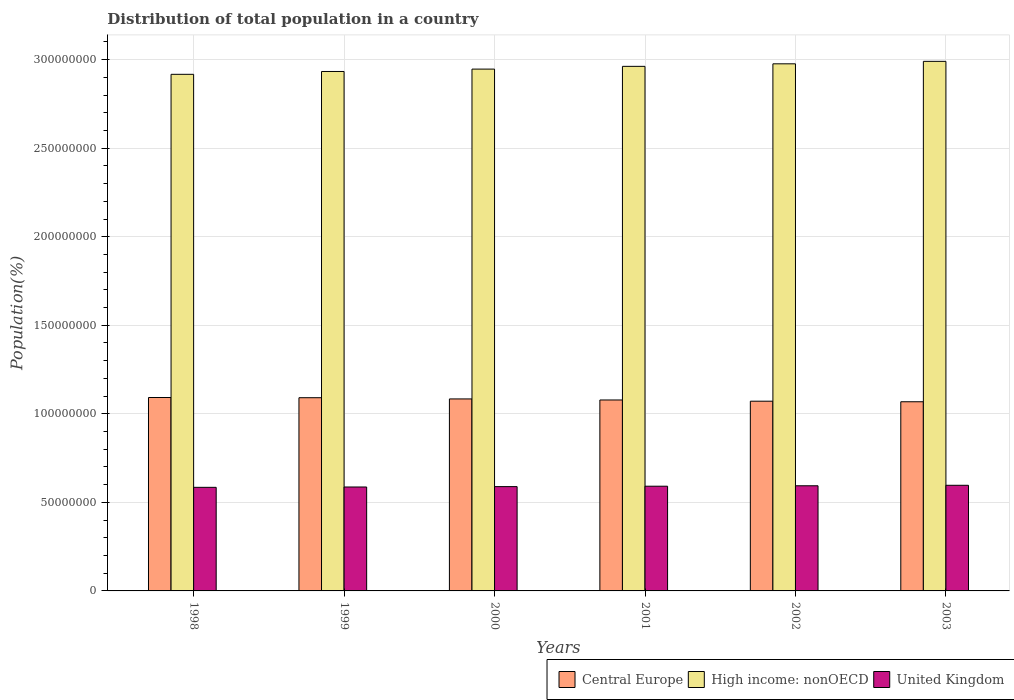How many different coloured bars are there?
Your response must be concise. 3. Are the number of bars on each tick of the X-axis equal?
Your answer should be very brief. Yes. How many bars are there on the 6th tick from the left?
Give a very brief answer. 3. How many bars are there on the 1st tick from the right?
Make the answer very short. 3. In how many cases, is the number of bars for a given year not equal to the number of legend labels?
Your answer should be compact. 0. What is the population of in United Kingdom in 2001?
Give a very brief answer. 5.91e+07. Across all years, what is the maximum population of in High income: nonOECD?
Give a very brief answer. 2.99e+08. Across all years, what is the minimum population of in United Kingdom?
Provide a succinct answer. 5.85e+07. What is the total population of in High income: nonOECD in the graph?
Offer a terse response. 1.77e+09. What is the difference between the population of in Central Europe in 2000 and that in 2001?
Keep it short and to the point. 5.94e+05. What is the difference between the population of in United Kingdom in 2000 and the population of in Central Europe in 1998?
Make the answer very short. -5.03e+07. What is the average population of in United Kingdom per year?
Offer a terse response. 5.90e+07. In the year 2001, what is the difference between the population of in Central Europe and population of in High income: nonOECD?
Your response must be concise. -1.88e+08. What is the ratio of the population of in Central Europe in 1998 to that in 2003?
Provide a short and direct response. 1.02. Is the population of in High income: nonOECD in 1998 less than that in 2000?
Your answer should be very brief. Yes. Is the difference between the population of in Central Europe in 2000 and 2002 greater than the difference between the population of in High income: nonOECD in 2000 and 2002?
Give a very brief answer. Yes. What is the difference between the highest and the second highest population of in Central Europe?
Your response must be concise. 1.14e+05. What is the difference between the highest and the lowest population of in United Kingdom?
Ensure brevity in your answer.  1.16e+06. In how many years, is the population of in Central Europe greater than the average population of in Central Europe taken over all years?
Offer a terse response. 3. Is the sum of the population of in United Kingdom in 1998 and 2002 greater than the maximum population of in High income: nonOECD across all years?
Provide a short and direct response. No. What does the 2nd bar from the left in 1998 represents?
Ensure brevity in your answer.  High income: nonOECD. What does the 2nd bar from the right in 2003 represents?
Keep it short and to the point. High income: nonOECD. How many bars are there?
Make the answer very short. 18. Are all the bars in the graph horizontal?
Your answer should be compact. No. How many years are there in the graph?
Make the answer very short. 6. What is the difference between two consecutive major ticks on the Y-axis?
Your response must be concise. 5.00e+07. Are the values on the major ticks of Y-axis written in scientific E-notation?
Offer a terse response. No. Does the graph contain any zero values?
Your response must be concise. No. Does the graph contain grids?
Keep it short and to the point. Yes. How many legend labels are there?
Give a very brief answer. 3. How are the legend labels stacked?
Your response must be concise. Horizontal. What is the title of the graph?
Your answer should be compact. Distribution of total population in a country. What is the label or title of the X-axis?
Provide a short and direct response. Years. What is the label or title of the Y-axis?
Offer a terse response. Population(%). What is the Population(%) of Central Europe in 1998?
Offer a very short reply. 1.09e+08. What is the Population(%) in High income: nonOECD in 1998?
Make the answer very short. 2.92e+08. What is the Population(%) of United Kingdom in 1998?
Provide a succinct answer. 5.85e+07. What is the Population(%) of Central Europe in 1999?
Offer a terse response. 1.09e+08. What is the Population(%) of High income: nonOECD in 1999?
Your answer should be very brief. 2.93e+08. What is the Population(%) of United Kingdom in 1999?
Offer a very short reply. 5.87e+07. What is the Population(%) of Central Europe in 2000?
Make the answer very short. 1.08e+08. What is the Population(%) in High income: nonOECD in 2000?
Your answer should be very brief. 2.95e+08. What is the Population(%) of United Kingdom in 2000?
Provide a succinct answer. 5.89e+07. What is the Population(%) in Central Europe in 2001?
Offer a very short reply. 1.08e+08. What is the Population(%) in High income: nonOECD in 2001?
Provide a short and direct response. 2.96e+08. What is the Population(%) in United Kingdom in 2001?
Provide a succinct answer. 5.91e+07. What is the Population(%) in Central Europe in 2002?
Ensure brevity in your answer.  1.07e+08. What is the Population(%) of High income: nonOECD in 2002?
Ensure brevity in your answer.  2.98e+08. What is the Population(%) of United Kingdom in 2002?
Offer a very short reply. 5.94e+07. What is the Population(%) in Central Europe in 2003?
Your response must be concise. 1.07e+08. What is the Population(%) in High income: nonOECD in 2003?
Give a very brief answer. 2.99e+08. What is the Population(%) in United Kingdom in 2003?
Provide a succinct answer. 5.96e+07. Across all years, what is the maximum Population(%) in Central Europe?
Give a very brief answer. 1.09e+08. Across all years, what is the maximum Population(%) of High income: nonOECD?
Keep it short and to the point. 2.99e+08. Across all years, what is the maximum Population(%) of United Kingdom?
Provide a succinct answer. 5.96e+07. Across all years, what is the minimum Population(%) of Central Europe?
Make the answer very short. 1.07e+08. Across all years, what is the minimum Population(%) of High income: nonOECD?
Your answer should be compact. 2.92e+08. Across all years, what is the minimum Population(%) of United Kingdom?
Keep it short and to the point. 5.85e+07. What is the total Population(%) of Central Europe in the graph?
Your answer should be very brief. 6.48e+08. What is the total Population(%) in High income: nonOECD in the graph?
Offer a terse response. 1.77e+09. What is the total Population(%) of United Kingdom in the graph?
Offer a terse response. 3.54e+08. What is the difference between the Population(%) of Central Europe in 1998 and that in 1999?
Your answer should be very brief. 1.14e+05. What is the difference between the Population(%) in High income: nonOECD in 1998 and that in 1999?
Your answer should be compact. -1.60e+06. What is the difference between the Population(%) of United Kingdom in 1998 and that in 1999?
Your answer should be very brief. -1.95e+05. What is the difference between the Population(%) of Central Europe in 1998 and that in 2000?
Provide a short and direct response. 8.02e+05. What is the difference between the Population(%) in High income: nonOECD in 1998 and that in 2000?
Provide a short and direct response. -2.95e+06. What is the difference between the Population(%) in United Kingdom in 1998 and that in 2000?
Provide a short and direct response. -4.05e+05. What is the difference between the Population(%) of Central Europe in 1998 and that in 2001?
Offer a terse response. 1.40e+06. What is the difference between the Population(%) in High income: nonOECD in 1998 and that in 2001?
Make the answer very short. -4.50e+06. What is the difference between the Population(%) in United Kingdom in 1998 and that in 2001?
Keep it short and to the point. -6.33e+05. What is the difference between the Population(%) in Central Europe in 1998 and that in 2002?
Provide a succinct answer. 2.08e+06. What is the difference between the Population(%) of High income: nonOECD in 1998 and that in 2002?
Offer a very short reply. -5.93e+06. What is the difference between the Population(%) of United Kingdom in 1998 and that in 2002?
Provide a short and direct response. -8.83e+05. What is the difference between the Population(%) of Central Europe in 1998 and that in 2003?
Give a very brief answer. 2.40e+06. What is the difference between the Population(%) of High income: nonOECD in 1998 and that in 2003?
Provide a succinct answer. -7.32e+06. What is the difference between the Population(%) of United Kingdom in 1998 and that in 2003?
Your answer should be very brief. -1.16e+06. What is the difference between the Population(%) in Central Europe in 1999 and that in 2000?
Give a very brief answer. 6.87e+05. What is the difference between the Population(%) of High income: nonOECD in 1999 and that in 2000?
Offer a very short reply. -1.35e+06. What is the difference between the Population(%) in United Kingdom in 1999 and that in 2000?
Your answer should be very brief. -2.10e+05. What is the difference between the Population(%) of Central Europe in 1999 and that in 2001?
Make the answer very short. 1.28e+06. What is the difference between the Population(%) of High income: nonOECD in 1999 and that in 2001?
Your answer should be very brief. -2.90e+06. What is the difference between the Population(%) in United Kingdom in 1999 and that in 2001?
Your response must be concise. -4.37e+05. What is the difference between the Population(%) of Central Europe in 1999 and that in 2002?
Offer a very short reply. 1.96e+06. What is the difference between the Population(%) in High income: nonOECD in 1999 and that in 2002?
Ensure brevity in your answer.  -4.33e+06. What is the difference between the Population(%) in United Kingdom in 1999 and that in 2002?
Provide a succinct answer. -6.88e+05. What is the difference between the Population(%) in Central Europe in 1999 and that in 2003?
Your answer should be compact. 2.28e+06. What is the difference between the Population(%) of High income: nonOECD in 1999 and that in 2003?
Offer a terse response. -5.72e+06. What is the difference between the Population(%) in United Kingdom in 1999 and that in 2003?
Offer a terse response. -9.65e+05. What is the difference between the Population(%) in Central Europe in 2000 and that in 2001?
Ensure brevity in your answer.  5.94e+05. What is the difference between the Population(%) of High income: nonOECD in 2000 and that in 2001?
Offer a very short reply. -1.55e+06. What is the difference between the Population(%) in United Kingdom in 2000 and that in 2001?
Keep it short and to the point. -2.27e+05. What is the difference between the Population(%) of Central Europe in 2000 and that in 2002?
Provide a succinct answer. 1.28e+06. What is the difference between the Population(%) in High income: nonOECD in 2000 and that in 2002?
Give a very brief answer. -2.98e+06. What is the difference between the Population(%) of United Kingdom in 2000 and that in 2002?
Provide a succinct answer. -4.78e+05. What is the difference between the Population(%) of Central Europe in 2000 and that in 2003?
Your answer should be very brief. 1.60e+06. What is the difference between the Population(%) in High income: nonOECD in 2000 and that in 2003?
Offer a very short reply. -4.37e+06. What is the difference between the Population(%) of United Kingdom in 2000 and that in 2003?
Offer a terse response. -7.55e+05. What is the difference between the Population(%) in Central Europe in 2001 and that in 2002?
Keep it short and to the point. 6.83e+05. What is the difference between the Population(%) of High income: nonOECD in 2001 and that in 2002?
Make the answer very short. -1.43e+06. What is the difference between the Population(%) in United Kingdom in 2001 and that in 2002?
Provide a succinct answer. -2.51e+05. What is the difference between the Population(%) in Central Europe in 2001 and that in 2003?
Offer a very short reply. 1.00e+06. What is the difference between the Population(%) in High income: nonOECD in 2001 and that in 2003?
Provide a succinct answer. -2.82e+06. What is the difference between the Population(%) in United Kingdom in 2001 and that in 2003?
Offer a terse response. -5.28e+05. What is the difference between the Population(%) in Central Europe in 2002 and that in 2003?
Provide a short and direct response. 3.20e+05. What is the difference between the Population(%) in High income: nonOECD in 2002 and that in 2003?
Provide a succinct answer. -1.39e+06. What is the difference between the Population(%) in United Kingdom in 2002 and that in 2003?
Offer a terse response. -2.77e+05. What is the difference between the Population(%) of Central Europe in 1998 and the Population(%) of High income: nonOECD in 1999?
Ensure brevity in your answer.  -1.84e+08. What is the difference between the Population(%) in Central Europe in 1998 and the Population(%) in United Kingdom in 1999?
Keep it short and to the point. 5.05e+07. What is the difference between the Population(%) of High income: nonOECD in 1998 and the Population(%) of United Kingdom in 1999?
Your response must be concise. 2.33e+08. What is the difference between the Population(%) in Central Europe in 1998 and the Population(%) in High income: nonOECD in 2000?
Your answer should be compact. -1.85e+08. What is the difference between the Population(%) of Central Europe in 1998 and the Population(%) of United Kingdom in 2000?
Provide a short and direct response. 5.03e+07. What is the difference between the Population(%) in High income: nonOECD in 1998 and the Population(%) in United Kingdom in 2000?
Give a very brief answer. 2.33e+08. What is the difference between the Population(%) of Central Europe in 1998 and the Population(%) of High income: nonOECD in 2001?
Offer a terse response. -1.87e+08. What is the difference between the Population(%) in Central Europe in 1998 and the Population(%) in United Kingdom in 2001?
Give a very brief answer. 5.01e+07. What is the difference between the Population(%) of High income: nonOECD in 1998 and the Population(%) of United Kingdom in 2001?
Provide a short and direct response. 2.33e+08. What is the difference between the Population(%) in Central Europe in 1998 and the Population(%) in High income: nonOECD in 2002?
Offer a very short reply. -1.88e+08. What is the difference between the Population(%) in Central Europe in 1998 and the Population(%) in United Kingdom in 2002?
Your answer should be compact. 4.98e+07. What is the difference between the Population(%) in High income: nonOECD in 1998 and the Population(%) in United Kingdom in 2002?
Provide a succinct answer. 2.32e+08. What is the difference between the Population(%) of Central Europe in 1998 and the Population(%) of High income: nonOECD in 2003?
Keep it short and to the point. -1.90e+08. What is the difference between the Population(%) in Central Europe in 1998 and the Population(%) in United Kingdom in 2003?
Give a very brief answer. 4.96e+07. What is the difference between the Population(%) of High income: nonOECD in 1998 and the Population(%) of United Kingdom in 2003?
Provide a short and direct response. 2.32e+08. What is the difference between the Population(%) in Central Europe in 1999 and the Population(%) in High income: nonOECD in 2000?
Your answer should be compact. -1.86e+08. What is the difference between the Population(%) in Central Europe in 1999 and the Population(%) in United Kingdom in 2000?
Your answer should be very brief. 5.02e+07. What is the difference between the Population(%) in High income: nonOECD in 1999 and the Population(%) in United Kingdom in 2000?
Make the answer very short. 2.34e+08. What is the difference between the Population(%) in Central Europe in 1999 and the Population(%) in High income: nonOECD in 2001?
Provide a short and direct response. -1.87e+08. What is the difference between the Population(%) in Central Europe in 1999 and the Population(%) in United Kingdom in 2001?
Your response must be concise. 5.00e+07. What is the difference between the Population(%) in High income: nonOECD in 1999 and the Population(%) in United Kingdom in 2001?
Offer a terse response. 2.34e+08. What is the difference between the Population(%) of Central Europe in 1999 and the Population(%) of High income: nonOECD in 2002?
Offer a very short reply. -1.89e+08. What is the difference between the Population(%) in Central Europe in 1999 and the Population(%) in United Kingdom in 2002?
Offer a terse response. 4.97e+07. What is the difference between the Population(%) in High income: nonOECD in 1999 and the Population(%) in United Kingdom in 2002?
Your answer should be compact. 2.34e+08. What is the difference between the Population(%) of Central Europe in 1999 and the Population(%) of High income: nonOECD in 2003?
Ensure brevity in your answer.  -1.90e+08. What is the difference between the Population(%) of Central Europe in 1999 and the Population(%) of United Kingdom in 2003?
Make the answer very short. 4.94e+07. What is the difference between the Population(%) of High income: nonOECD in 1999 and the Population(%) of United Kingdom in 2003?
Offer a very short reply. 2.34e+08. What is the difference between the Population(%) in Central Europe in 2000 and the Population(%) in High income: nonOECD in 2001?
Provide a short and direct response. -1.88e+08. What is the difference between the Population(%) of Central Europe in 2000 and the Population(%) of United Kingdom in 2001?
Ensure brevity in your answer.  4.93e+07. What is the difference between the Population(%) in High income: nonOECD in 2000 and the Population(%) in United Kingdom in 2001?
Your response must be concise. 2.36e+08. What is the difference between the Population(%) in Central Europe in 2000 and the Population(%) in High income: nonOECD in 2002?
Provide a succinct answer. -1.89e+08. What is the difference between the Population(%) in Central Europe in 2000 and the Population(%) in United Kingdom in 2002?
Provide a short and direct response. 4.90e+07. What is the difference between the Population(%) in High income: nonOECD in 2000 and the Population(%) in United Kingdom in 2002?
Offer a terse response. 2.35e+08. What is the difference between the Population(%) in Central Europe in 2000 and the Population(%) in High income: nonOECD in 2003?
Give a very brief answer. -1.91e+08. What is the difference between the Population(%) in Central Europe in 2000 and the Population(%) in United Kingdom in 2003?
Your answer should be very brief. 4.88e+07. What is the difference between the Population(%) of High income: nonOECD in 2000 and the Population(%) of United Kingdom in 2003?
Your response must be concise. 2.35e+08. What is the difference between the Population(%) of Central Europe in 2001 and the Population(%) of High income: nonOECD in 2002?
Provide a succinct answer. -1.90e+08. What is the difference between the Population(%) in Central Europe in 2001 and the Population(%) in United Kingdom in 2002?
Your answer should be compact. 4.84e+07. What is the difference between the Population(%) in High income: nonOECD in 2001 and the Population(%) in United Kingdom in 2002?
Offer a terse response. 2.37e+08. What is the difference between the Population(%) of Central Europe in 2001 and the Population(%) of High income: nonOECD in 2003?
Provide a succinct answer. -1.91e+08. What is the difference between the Population(%) in Central Europe in 2001 and the Population(%) in United Kingdom in 2003?
Provide a short and direct response. 4.82e+07. What is the difference between the Population(%) of High income: nonOECD in 2001 and the Population(%) of United Kingdom in 2003?
Your answer should be compact. 2.37e+08. What is the difference between the Population(%) of Central Europe in 2002 and the Population(%) of High income: nonOECD in 2003?
Keep it short and to the point. -1.92e+08. What is the difference between the Population(%) of Central Europe in 2002 and the Population(%) of United Kingdom in 2003?
Make the answer very short. 4.75e+07. What is the difference between the Population(%) in High income: nonOECD in 2002 and the Population(%) in United Kingdom in 2003?
Provide a succinct answer. 2.38e+08. What is the average Population(%) in Central Europe per year?
Your answer should be very brief. 1.08e+08. What is the average Population(%) in High income: nonOECD per year?
Offer a very short reply. 2.95e+08. What is the average Population(%) of United Kingdom per year?
Give a very brief answer. 5.90e+07. In the year 1998, what is the difference between the Population(%) of Central Europe and Population(%) of High income: nonOECD?
Offer a terse response. -1.82e+08. In the year 1998, what is the difference between the Population(%) of Central Europe and Population(%) of United Kingdom?
Offer a very short reply. 5.07e+07. In the year 1998, what is the difference between the Population(%) in High income: nonOECD and Population(%) in United Kingdom?
Offer a very short reply. 2.33e+08. In the year 1999, what is the difference between the Population(%) in Central Europe and Population(%) in High income: nonOECD?
Provide a succinct answer. -1.84e+08. In the year 1999, what is the difference between the Population(%) of Central Europe and Population(%) of United Kingdom?
Provide a succinct answer. 5.04e+07. In the year 1999, what is the difference between the Population(%) in High income: nonOECD and Population(%) in United Kingdom?
Your response must be concise. 2.35e+08. In the year 2000, what is the difference between the Population(%) of Central Europe and Population(%) of High income: nonOECD?
Ensure brevity in your answer.  -1.86e+08. In the year 2000, what is the difference between the Population(%) of Central Europe and Population(%) of United Kingdom?
Give a very brief answer. 4.95e+07. In the year 2000, what is the difference between the Population(%) in High income: nonOECD and Population(%) in United Kingdom?
Offer a terse response. 2.36e+08. In the year 2001, what is the difference between the Population(%) of Central Europe and Population(%) of High income: nonOECD?
Provide a short and direct response. -1.88e+08. In the year 2001, what is the difference between the Population(%) of Central Europe and Population(%) of United Kingdom?
Provide a succinct answer. 4.87e+07. In the year 2001, what is the difference between the Population(%) of High income: nonOECD and Population(%) of United Kingdom?
Offer a terse response. 2.37e+08. In the year 2002, what is the difference between the Population(%) of Central Europe and Population(%) of High income: nonOECD?
Your response must be concise. -1.90e+08. In the year 2002, what is the difference between the Population(%) in Central Europe and Population(%) in United Kingdom?
Your answer should be compact. 4.78e+07. In the year 2002, what is the difference between the Population(%) of High income: nonOECD and Population(%) of United Kingdom?
Your response must be concise. 2.38e+08. In the year 2003, what is the difference between the Population(%) in Central Europe and Population(%) in High income: nonOECD?
Ensure brevity in your answer.  -1.92e+08. In the year 2003, what is the difference between the Population(%) in Central Europe and Population(%) in United Kingdom?
Give a very brief answer. 4.72e+07. In the year 2003, what is the difference between the Population(%) in High income: nonOECD and Population(%) in United Kingdom?
Make the answer very short. 2.39e+08. What is the ratio of the Population(%) in United Kingdom in 1998 to that in 1999?
Ensure brevity in your answer.  1. What is the ratio of the Population(%) in Central Europe in 1998 to that in 2000?
Provide a short and direct response. 1.01. What is the ratio of the Population(%) in United Kingdom in 1998 to that in 2000?
Provide a succinct answer. 0.99. What is the ratio of the Population(%) of Central Europe in 1998 to that in 2001?
Ensure brevity in your answer.  1.01. What is the ratio of the Population(%) in United Kingdom in 1998 to that in 2001?
Your answer should be compact. 0.99. What is the ratio of the Population(%) in Central Europe in 1998 to that in 2002?
Offer a terse response. 1.02. What is the ratio of the Population(%) in High income: nonOECD in 1998 to that in 2002?
Make the answer very short. 0.98. What is the ratio of the Population(%) in United Kingdom in 1998 to that in 2002?
Your response must be concise. 0.99. What is the ratio of the Population(%) of Central Europe in 1998 to that in 2003?
Offer a very short reply. 1.02. What is the ratio of the Population(%) of High income: nonOECD in 1998 to that in 2003?
Keep it short and to the point. 0.98. What is the ratio of the Population(%) of United Kingdom in 1998 to that in 2003?
Keep it short and to the point. 0.98. What is the ratio of the Population(%) in United Kingdom in 1999 to that in 2000?
Give a very brief answer. 1. What is the ratio of the Population(%) in Central Europe in 1999 to that in 2001?
Ensure brevity in your answer.  1.01. What is the ratio of the Population(%) of High income: nonOECD in 1999 to that in 2001?
Provide a short and direct response. 0.99. What is the ratio of the Population(%) in United Kingdom in 1999 to that in 2001?
Your answer should be compact. 0.99. What is the ratio of the Population(%) of Central Europe in 1999 to that in 2002?
Your answer should be compact. 1.02. What is the ratio of the Population(%) of High income: nonOECD in 1999 to that in 2002?
Provide a succinct answer. 0.99. What is the ratio of the Population(%) of United Kingdom in 1999 to that in 2002?
Make the answer very short. 0.99. What is the ratio of the Population(%) of Central Europe in 1999 to that in 2003?
Offer a terse response. 1.02. What is the ratio of the Population(%) in High income: nonOECD in 1999 to that in 2003?
Your answer should be compact. 0.98. What is the ratio of the Population(%) of United Kingdom in 1999 to that in 2003?
Your response must be concise. 0.98. What is the ratio of the Population(%) of Central Europe in 2000 to that in 2001?
Ensure brevity in your answer.  1.01. What is the ratio of the Population(%) in Central Europe in 2000 to that in 2002?
Offer a very short reply. 1.01. What is the ratio of the Population(%) in High income: nonOECD in 2000 to that in 2002?
Your response must be concise. 0.99. What is the ratio of the Population(%) of United Kingdom in 2000 to that in 2002?
Your response must be concise. 0.99. What is the ratio of the Population(%) of Central Europe in 2000 to that in 2003?
Give a very brief answer. 1.01. What is the ratio of the Population(%) in High income: nonOECD in 2000 to that in 2003?
Offer a terse response. 0.99. What is the ratio of the Population(%) of United Kingdom in 2000 to that in 2003?
Give a very brief answer. 0.99. What is the ratio of the Population(%) of Central Europe in 2001 to that in 2002?
Ensure brevity in your answer.  1.01. What is the ratio of the Population(%) of High income: nonOECD in 2001 to that in 2002?
Provide a short and direct response. 1. What is the ratio of the Population(%) in Central Europe in 2001 to that in 2003?
Offer a terse response. 1.01. What is the ratio of the Population(%) of High income: nonOECD in 2001 to that in 2003?
Your response must be concise. 0.99. What is the ratio of the Population(%) of Central Europe in 2002 to that in 2003?
Your answer should be very brief. 1. What is the ratio of the Population(%) of United Kingdom in 2002 to that in 2003?
Keep it short and to the point. 1. What is the difference between the highest and the second highest Population(%) in Central Europe?
Offer a very short reply. 1.14e+05. What is the difference between the highest and the second highest Population(%) in High income: nonOECD?
Make the answer very short. 1.39e+06. What is the difference between the highest and the second highest Population(%) of United Kingdom?
Give a very brief answer. 2.77e+05. What is the difference between the highest and the lowest Population(%) of Central Europe?
Provide a short and direct response. 2.40e+06. What is the difference between the highest and the lowest Population(%) in High income: nonOECD?
Your response must be concise. 7.32e+06. What is the difference between the highest and the lowest Population(%) of United Kingdom?
Your answer should be compact. 1.16e+06. 